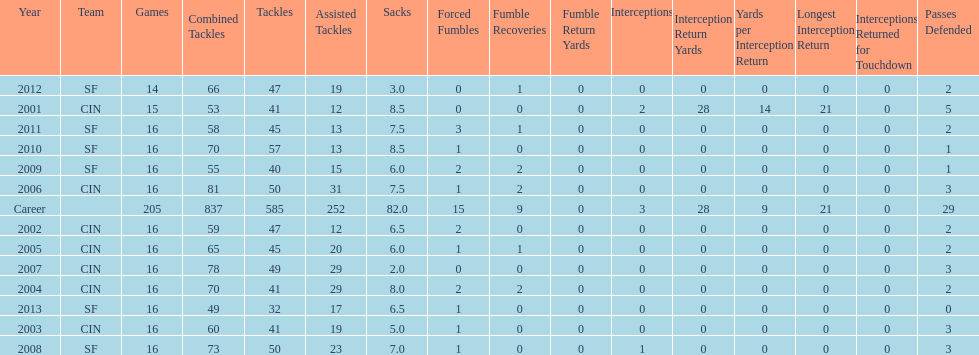How many seasons had combined tackles of 70 or more? 5. Would you be able to parse every entry in this table? {'header': ['Year', 'Team', 'Games', 'Combined Tackles', 'Tackles', 'Assisted Tackles', 'Sacks', 'Forced Fumbles', 'Fumble Recoveries', 'Fumble Return Yards', 'Interceptions', 'Interception Return Yards', 'Yards per Interception Return', 'Longest Interception Return', 'Interceptions Returned for Touchdown', 'Passes Defended'], 'rows': [['2012', 'SF', '14', '66', '47', '19', '3.0', '0', '1', '0', '0', '0', '0', '0', '0', '2'], ['2001', 'CIN', '15', '53', '41', '12', '8.5', '0', '0', '0', '2', '28', '14', '21', '0', '5'], ['2011', 'SF', '16', '58', '45', '13', '7.5', '3', '1', '0', '0', '0', '0', '0', '0', '2'], ['2010', 'SF', '16', '70', '57', '13', '8.5', '1', '0', '0', '0', '0', '0', '0', '0', '1'], ['2009', 'SF', '16', '55', '40', '15', '6.0', '2', '2', '0', '0', '0', '0', '0', '0', '1'], ['2006', 'CIN', '16', '81', '50', '31', '7.5', '1', '2', '0', '0', '0', '0', '0', '0', '3'], ['Career', '', '205', '837', '585', '252', '82.0', '15', '9', '0', '3', '28', '9', '21', '0', '29'], ['2002', 'CIN', '16', '59', '47', '12', '6.5', '2', '0', '0', '0', '0', '0', '0', '0', '2'], ['2005', 'CIN', '16', '65', '45', '20', '6.0', '1', '1', '0', '0', '0', '0', '0', '0', '2'], ['2007', 'CIN', '16', '78', '49', '29', '2.0', '0', '0', '0', '0', '0', '0', '0', '0', '3'], ['2004', 'CIN', '16', '70', '41', '29', '8.0', '2', '2', '0', '0', '0', '0', '0', '0', '2'], ['2013', 'SF', '16', '49', '32', '17', '6.5', '1', '0', '0', '0', '0', '0', '0', '0', '0'], ['2003', 'CIN', '16', '60', '41', '19', '5.0', '1', '0', '0', '0', '0', '0', '0', '0', '3'], ['2008', 'SF', '16', '73', '50', '23', '7.0', '1', '0', '0', '1', '0', '0', '0', '0', '3']]} 